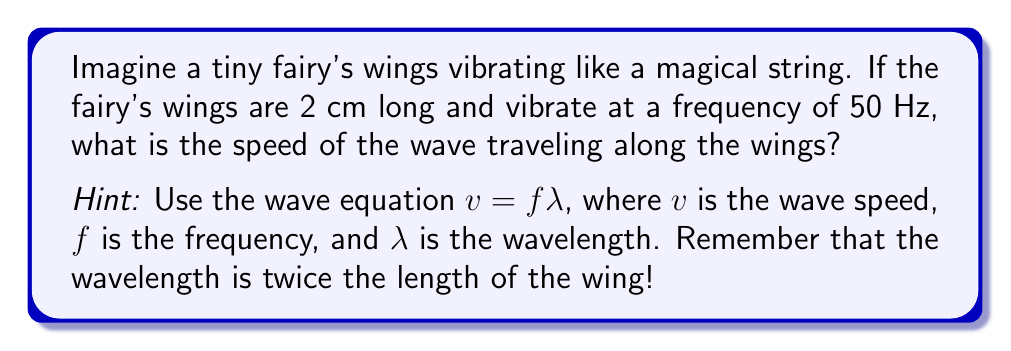Solve this math problem. Let's solve this magical problem step by step:

1. We know the frequency: $f = 50$ Hz

2. The length of the fairy's wings is 2 cm. But remember, the wavelength is twice this length:
   $\lambda = 2 \times 2 \text{ cm} = 4 \text{ cm} = 0.04 \text{ m}$

3. We can use the wave equation:
   $v = f \lambda$

4. Now, let's substitute our values:
   $v = 50 \text{ Hz} \times 0.04 \text{ m}$

5. Calculate:
   $v = 2 \text{ m/s}$

So, the wave travels along the fairy's wings at a speed of 2 meters per second!
Answer: 2 m/s 